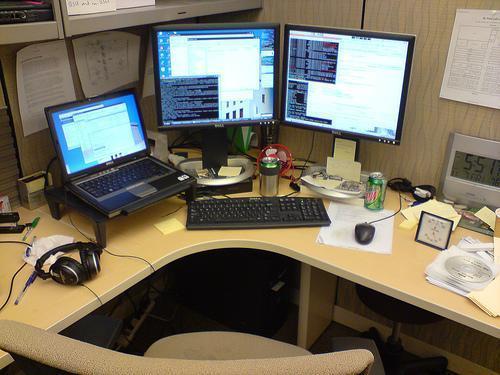How many screens are on the desk?
Give a very brief answer. 3. How many laptops are on the desk?
Give a very brief answer. 1. How many cans are on the desk?
Give a very brief answer. 2. 